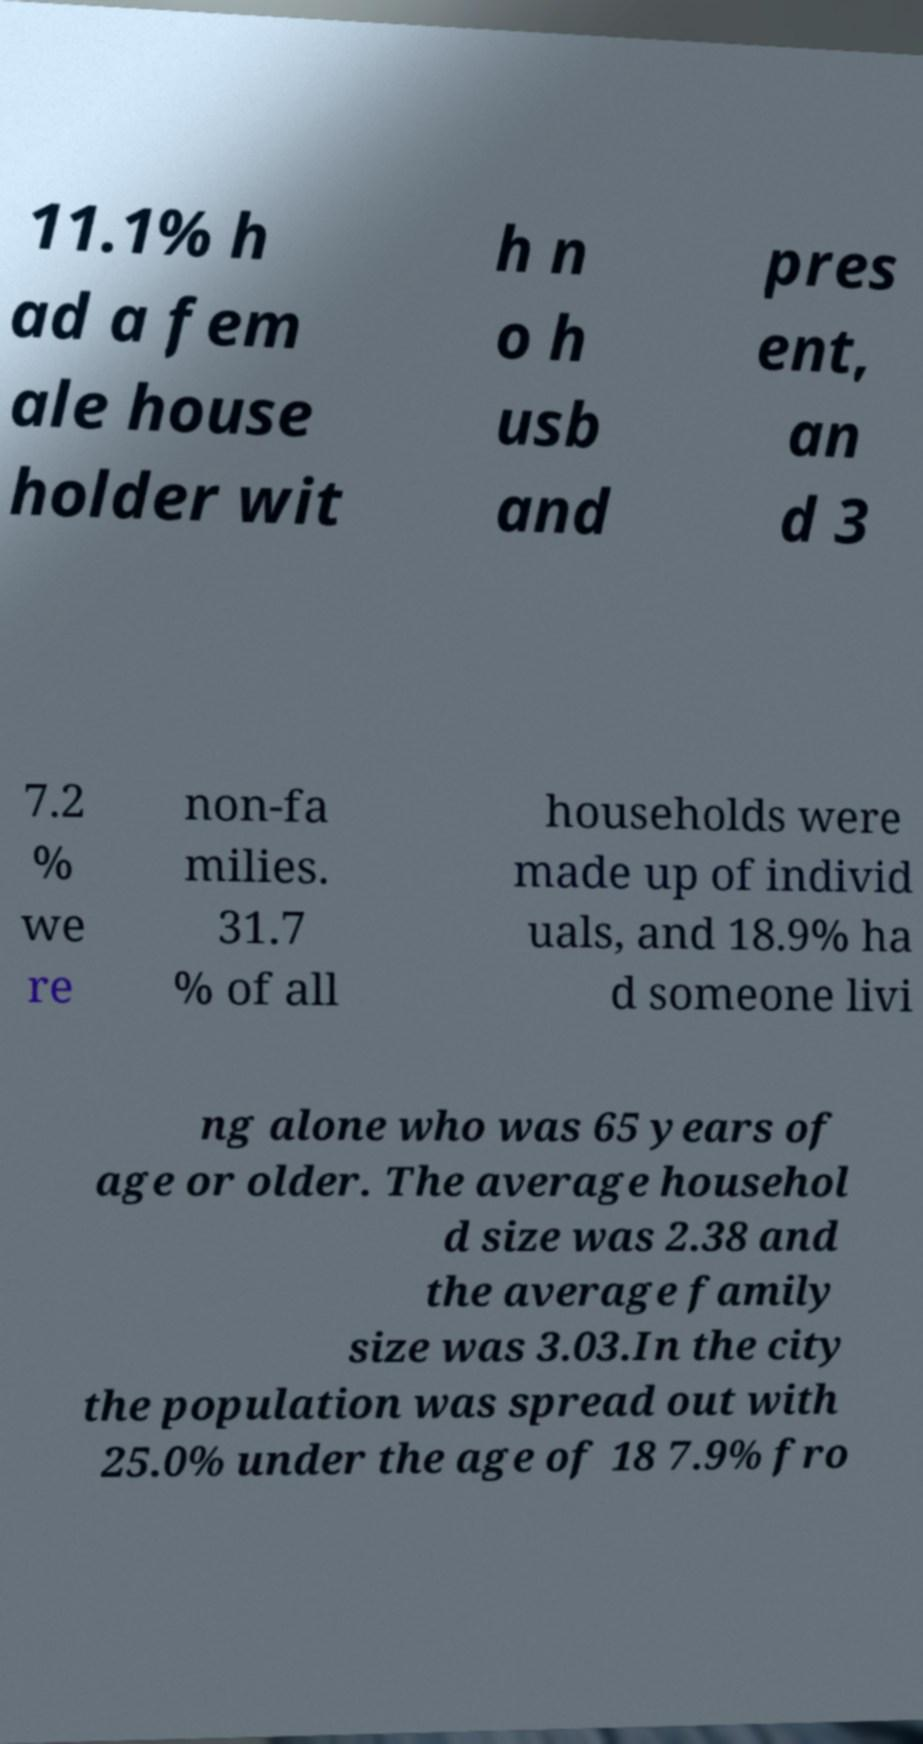Can you read and provide the text displayed in the image?This photo seems to have some interesting text. Can you extract and type it out for me? 11.1% h ad a fem ale house holder wit h n o h usb and pres ent, an d 3 7.2 % we re non-fa milies. 31.7 % of all households were made up of individ uals, and 18.9% ha d someone livi ng alone who was 65 years of age or older. The average househol d size was 2.38 and the average family size was 3.03.In the city the population was spread out with 25.0% under the age of 18 7.9% fro 